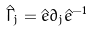<formula> <loc_0><loc_0><loc_500><loc_500>\hat { \Gamma } _ { j } = \hat { e } \partial _ { j } \hat { e } ^ { - 1 }</formula> 